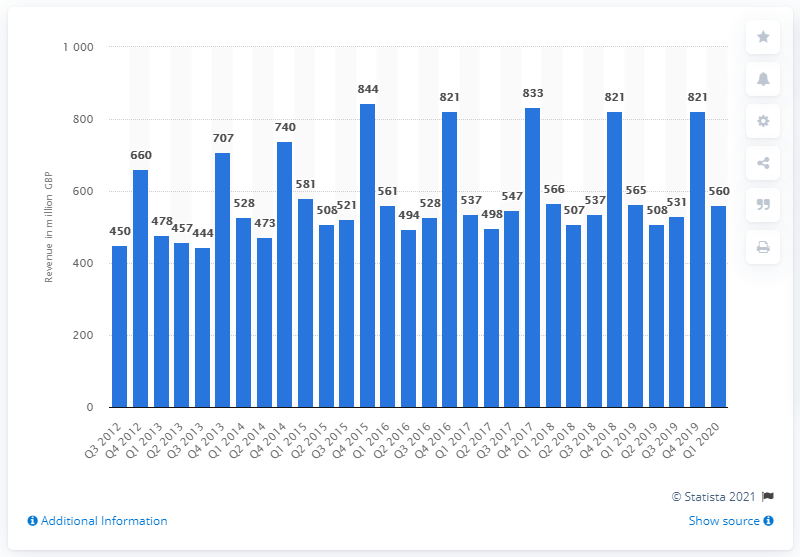Specify some key components in this picture. In the first quarter of 2020, small domestic appliances generated revenue of $560 million. 